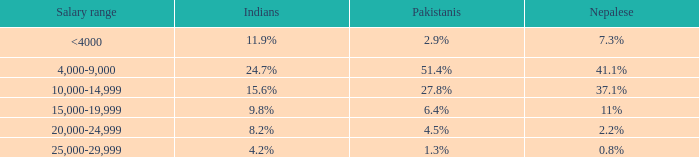If the working force of HK is 32.8%, what are the Pakistanis' %?  51.4%. 